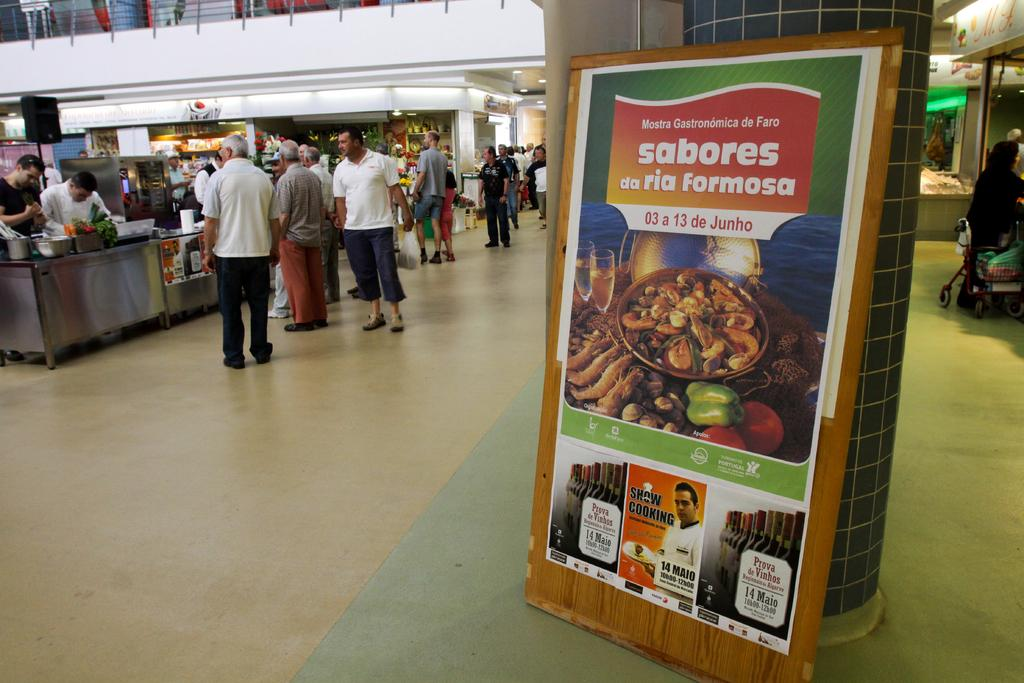What are the people in the image doing? The people in the image are standing. Where are the people standing in the image? The people are standing on the floor. What can be seen on the right side of the image? There is an advertisement board on the right side of the image. What is visible in the background of the image? There are stalls visible in the background of the image. What type of sweater is the girl wearing in the image? There are no girls or sweaters present in the image. How does the gate open in the image? There is no gate present in the image. 